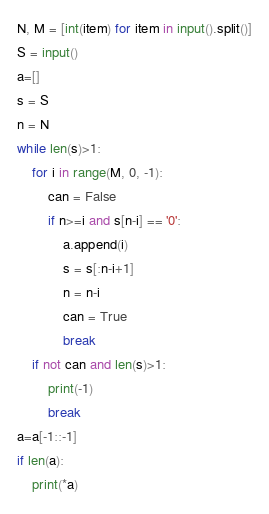Convert code to text. <code><loc_0><loc_0><loc_500><loc_500><_Python_>N, M = [int(item) for item in input().split()]
S = input()
a=[]
s = S
n = N
while len(s)>1:
    for i in range(M, 0, -1):
        can = False
        if n>=i and s[n-i] == '0':
            a.append(i)
            s = s[:n-i+1]
            n = n-i
            can = True
            break
    if not can and len(s)>1:
        print(-1)
        break
a=a[-1::-1]
if len(a):
    print(*a)</code> 